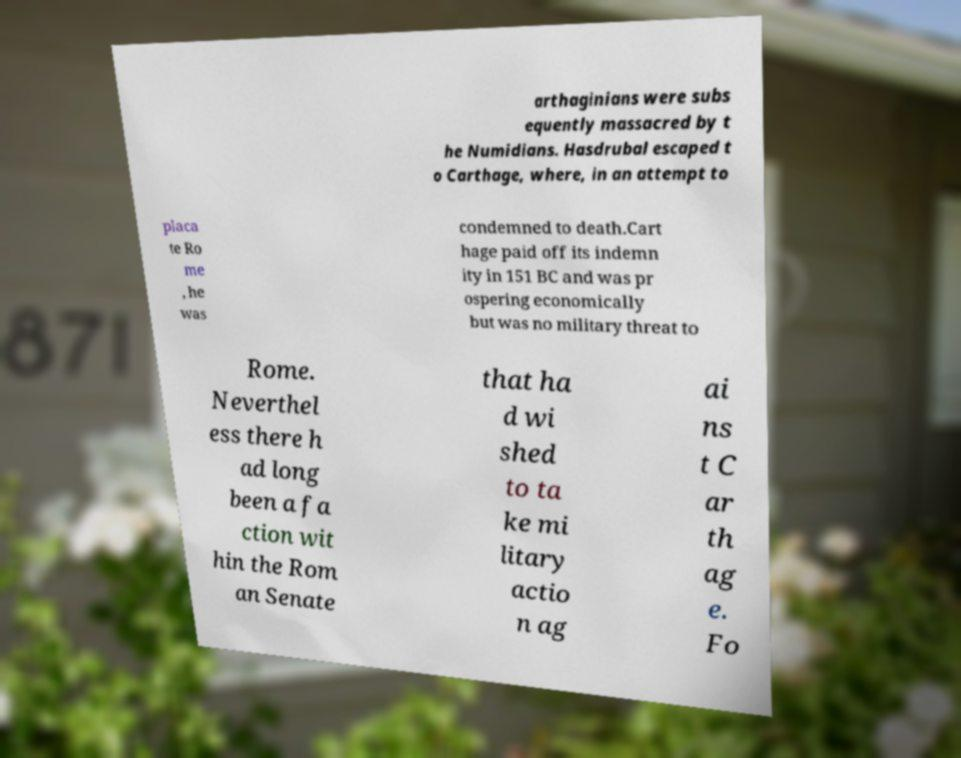Can you accurately transcribe the text from the provided image for me? arthaginians were subs equently massacred by t he Numidians. Hasdrubal escaped t o Carthage, where, in an attempt to placa te Ro me , he was condemned to death.Cart hage paid off its indemn ity in 151 BC and was pr ospering economically but was no military threat to Rome. Neverthel ess there h ad long been a fa ction wit hin the Rom an Senate that ha d wi shed to ta ke mi litary actio n ag ai ns t C ar th ag e. Fo 